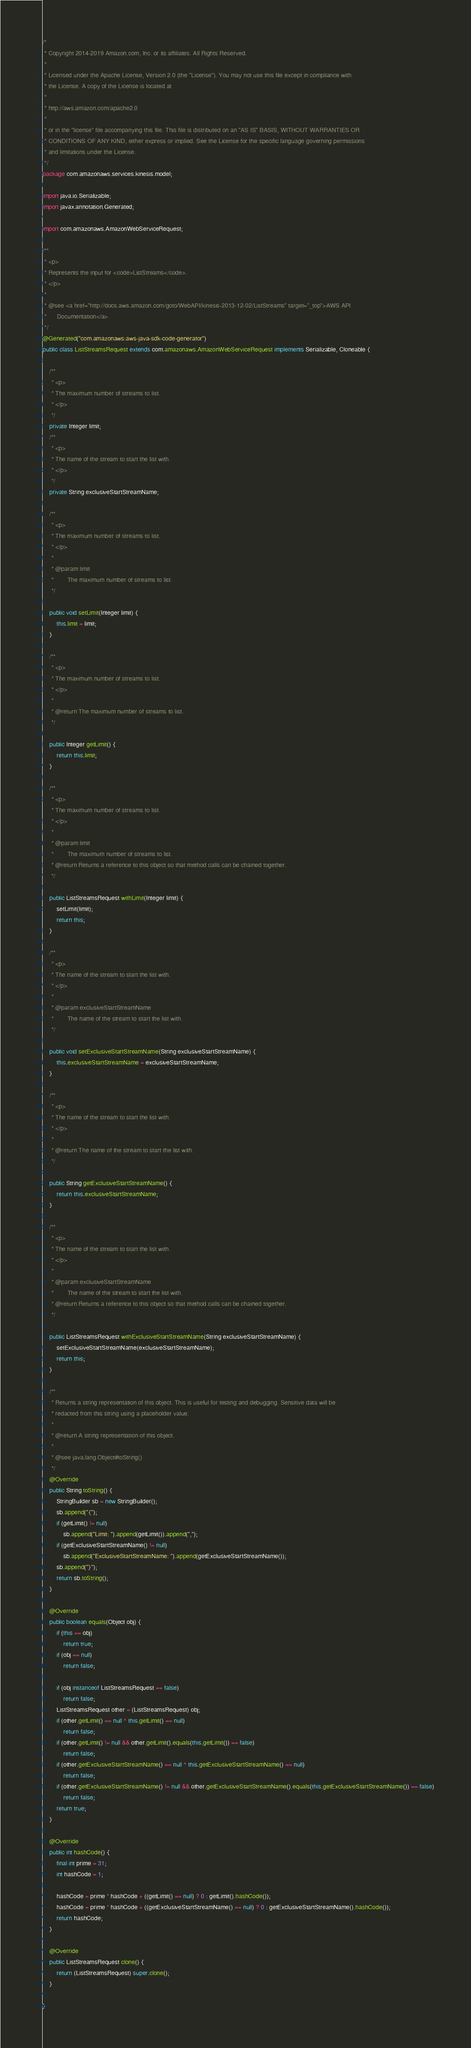<code> <loc_0><loc_0><loc_500><loc_500><_Java_>/*
 * Copyright 2014-2019 Amazon.com, Inc. or its affiliates. All Rights Reserved.
 * 
 * Licensed under the Apache License, Version 2.0 (the "License"). You may not use this file except in compliance with
 * the License. A copy of the License is located at
 * 
 * http://aws.amazon.com/apache2.0
 * 
 * or in the "license" file accompanying this file. This file is distributed on an "AS IS" BASIS, WITHOUT WARRANTIES OR
 * CONDITIONS OF ANY KIND, either express or implied. See the License for the specific language governing permissions
 * and limitations under the License.
 */
package com.amazonaws.services.kinesis.model;

import java.io.Serializable;
import javax.annotation.Generated;

import com.amazonaws.AmazonWebServiceRequest;

/**
 * <p>
 * Represents the input for <code>ListStreams</code>.
 * </p>
 * 
 * @see <a href="http://docs.aws.amazon.com/goto/WebAPI/kinesis-2013-12-02/ListStreams" target="_top">AWS API
 *      Documentation</a>
 */
@Generated("com.amazonaws:aws-java-sdk-code-generator")
public class ListStreamsRequest extends com.amazonaws.AmazonWebServiceRequest implements Serializable, Cloneable {

    /**
     * <p>
     * The maximum number of streams to list.
     * </p>
     */
    private Integer limit;
    /**
     * <p>
     * The name of the stream to start the list with.
     * </p>
     */
    private String exclusiveStartStreamName;

    /**
     * <p>
     * The maximum number of streams to list.
     * </p>
     * 
     * @param limit
     *        The maximum number of streams to list.
     */

    public void setLimit(Integer limit) {
        this.limit = limit;
    }

    /**
     * <p>
     * The maximum number of streams to list.
     * </p>
     * 
     * @return The maximum number of streams to list.
     */

    public Integer getLimit() {
        return this.limit;
    }

    /**
     * <p>
     * The maximum number of streams to list.
     * </p>
     * 
     * @param limit
     *        The maximum number of streams to list.
     * @return Returns a reference to this object so that method calls can be chained together.
     */

    public ListStreamsRequest withLimit(Integer limit) {
        setLimit(limit);
        return this;
    }

    /**
     * <p>
     * The name of the stream to start the list with.
     * </p>
     * 
     * @param exclusiveStartStreamName
     *        The name of the stream to start the list with.
     */

    public void setExclusiveStartStreamName(String exclusiveStartStreamName) {
        this.exclusiveStartStreamName = exclusiveStartStreamName;
    }

    /**
     * <p>
     * The name of the stream to start the list with.
     * </p>
     * 
     * @return The name of the stream to start the list with.
     */

    public String getExclusiveStartStreamName() {
        return this.exclusiveStartStreamName;
    }

    /**
     * <p>
     * The name of the stream to start the list with.
     * </p>
     * 
     * @param exclusiveStartStreamName
     *        The name of the stream to start the list with.
     * @return Returns a reference to this object so that method calls can be chained together.
     */

    public ListStreamsRequest withExclusiveStartStreamName(String exclusiveStartStreamName) {
        setExclusiveStartStreamName(exclusiveStartStreamName);
        return this;
    }

    /**
     * Returns a string representation of this object. This is useful for testing and debugging. Sensitive data will be
     * redacted from this string using a placeholder value.
     *
     * @return A string representation of this object.
     *
     * @see java.lang.Object#toString()
     */
    @Override
    public String toString() {
        StringBuilder sb = new StringBuilder();
        sb.append("{");
        if (getLimit() != null)
            sb.append("Limit: ").append(getLimit()).append(",");
        if (getExclusiveStartStreamName() != null)
            sb.append("ExclusiveStartStreamName: ").append(getExclusiveStartStreamName());
        sb.append("}");
        return sb.toString();
    }

    @Override
    public boolean equals(Object obj) {
        if (this == obj)
            return true;
        if (obj == null)
            return false;

        if (obj instanceof ListStreamsRequest == false)
            return false;
        ListStreamsRequest other = (ListStreamsRequest) obj;
        if (other.getLimit() == null ^ this.getLimit() == null)
            return false;
        if (other.getLimit() != null && other.getLimit().equals(this.getLimit()) == false)
            return false;
        if (other.getExclusiveStartStreamName() == null ^ this.getExclusiveStartStreamName() == null)
            return false;
        if (other.getExclusiveStartStreamName() != null && other.getExclusiveStartStreamName().equals(this.getExclusiveStartStreamName()) == false)
            return false;
        return true;
    }

    @Override
    public int hashCode() {
        final int prime = 31;
        int hashCode = 1;

        hashCode = prime * hashCode + ((getLimit() == null) ? 0 : getLimit().hashCode());
        hashCode = prime * hashCode + ((getExclusiveStartStreamName() == null) ? 0 : getExclusiveStartStreamName().hashCode());
        return hashCode;
    }

    @Override
    public ListStreamsRequest clone() {
        return (ListStreamsRequest) super.clone();
    }

}
</code> 